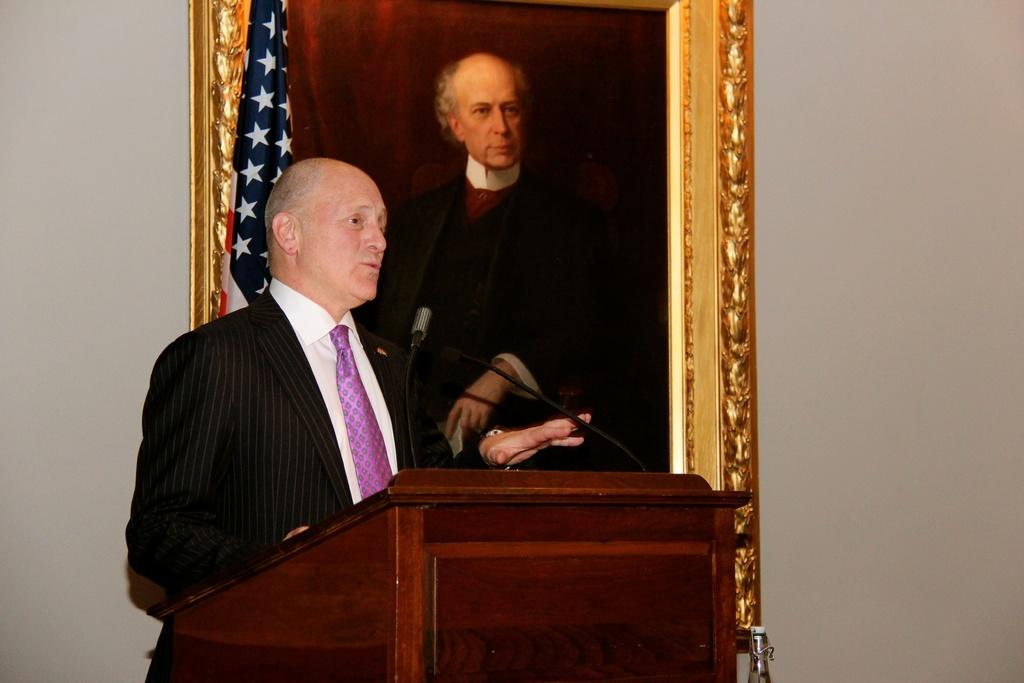What is the person in the image doing? The person is standing in front of a podium. What can be seen on the wall in the image? There is a photo frame on the wall. What is located at the top of the image? There is a flag at the top of the image. What type of pets are being led by the person in the image? There are no pets present in the image, and the person is not leading anything. 